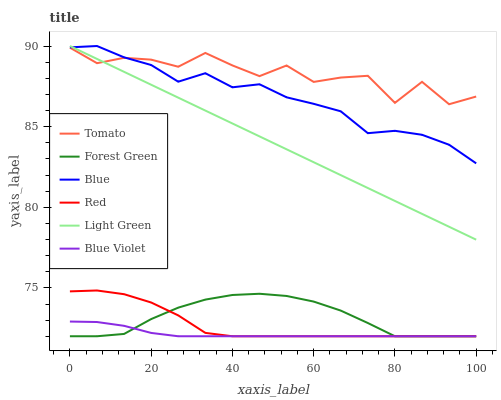Does Blue Violet have the minimum area under the curve?
Answer yes or no. Yes. Does Tomato have the maximum area under the curve?
Answer yes or no. Yes. Does Blue have the minimum area under the curve?
Answer yes or no. No. Does Blue have the maximum area under the curve?
Answer yes or no. No. Is Light Green the smoothest?
Answer yes or no. Yes. Is Tomato the roughest?
Answer yes or no. Yes. Is Blue the smoothest?
Answer yes or no. No. Is Blue the roughest?
Answer yes or no. No. Does Forest Green have the lowest value?
Answer yes or no. Yes. Does Blue have the lowest value?
Answer yes or no. No. Does Light Green have the highest value?
Answer yes or no. Yes. Does Forest Green have the highest value?
Answer yes or no. No. Is Red less than Light Green?
Answer yes or no. Yes. Is Light Green greater than Red?
Answer yes or no. Yes. Does Blue intersect Tomato?
Answer yes or no. Yes. Is Blue less than Tomato?
Answer yes or no. No. Is Blue greater than Tomato?
Answer yes or no. No. Does Red intersect Light Green?
Answer yes or no. No. 